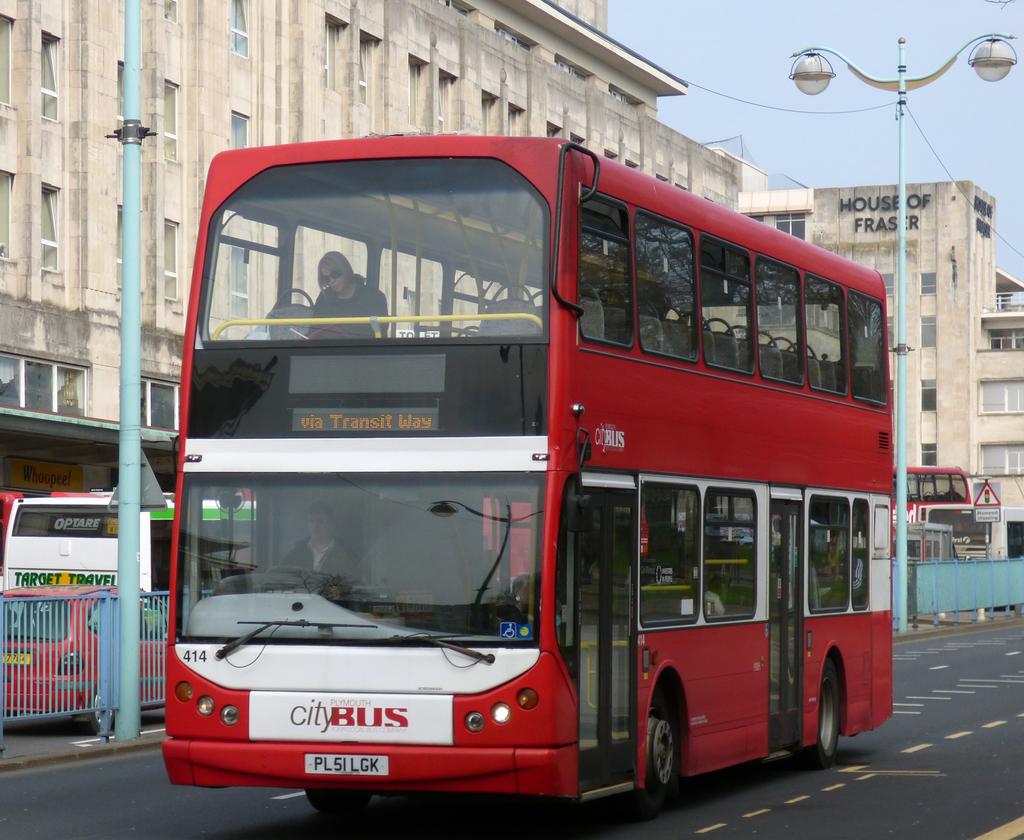Does this bus have two levels?
Provide a succinct answer. Answering does not require reading text in the image. What´s the number of this bus?
Your answer should be compact. 414. 